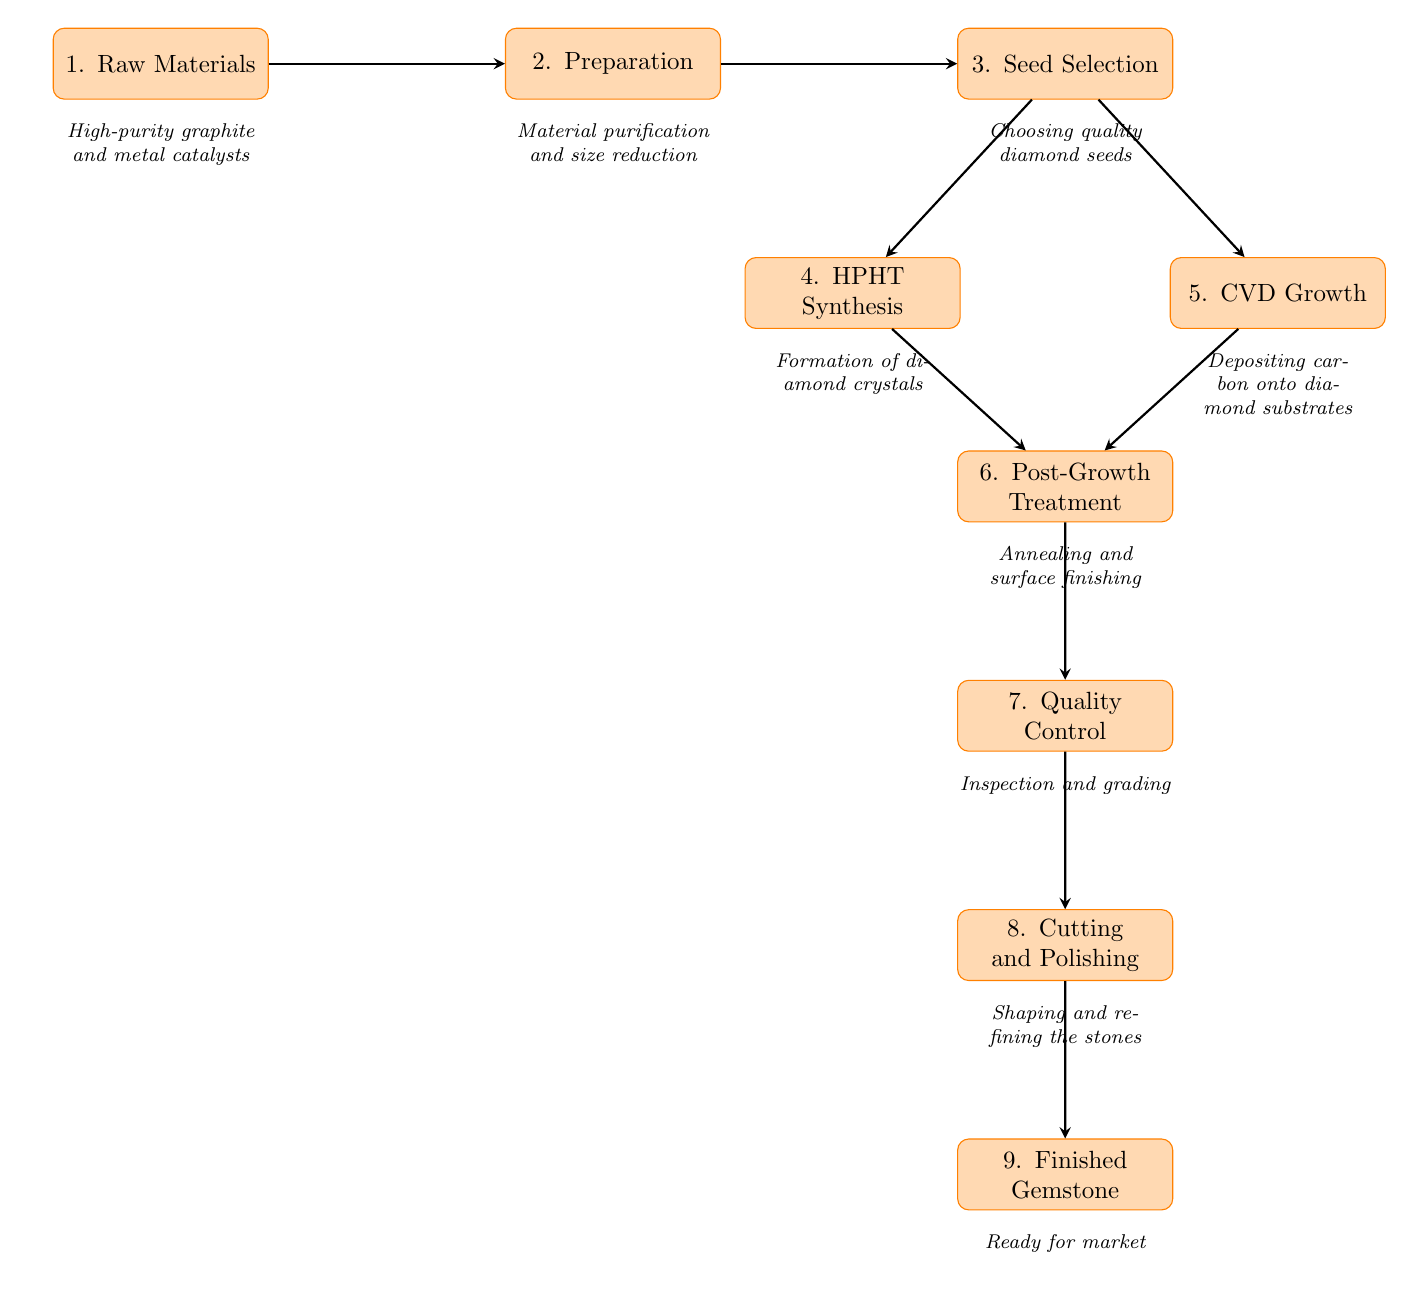What is the first step in the process flowchart? The first step in the process flowchart, indicated at the top of the diagram, is the node labeled "1. Raw Materials."
Answer: Raw Materials What materials are used in the raw materials stage? Below the "1. Raw Materials" node, the description mentions "High-purity graphite and metal catalysts" as the materials used.
Answer: High-purity graphite and metal catalysts How many synthesis methods are included in the process? The diagram shows two paths after "3. Seed Selection": "4. HPHT Synthesis" and "5. CVD Growth", indicating there are two synthesis methods.
Answer: 2 What type of treatment follows the growth processes? The treatment that follows both synthesis processes "4. HPHT Synthesis" and "5. CVD Growth" is noted as "6. Post-Growth Treatment."
Answer: Post-Growth Treatment What is the final output of the flowchart? The final output node, at the bottom of the diagram, is labeled "9. Finished Gemstone," indicating that this is the end product of the process.
Answer: Finished Gemstone What is performed after post-growth treatment? Following the "6. Post-Growth Treatment", the next process indicated is "7. Quality Control."
Answer: Quality Control Which step includes the selection of diamond seeds? The node "3. Seed Selection" explicitly states that this step involves choosing quality diamond seeds, making it the part of the process where seeds are selected.
Answer: Seed Selection What is included in the cutting and polishing step? According to the description below the "8. Cutting and Polishing" node, it involves "Shaping and refining the stones," which describes what happens during this step.
Answer: Shaping and refining the stones 